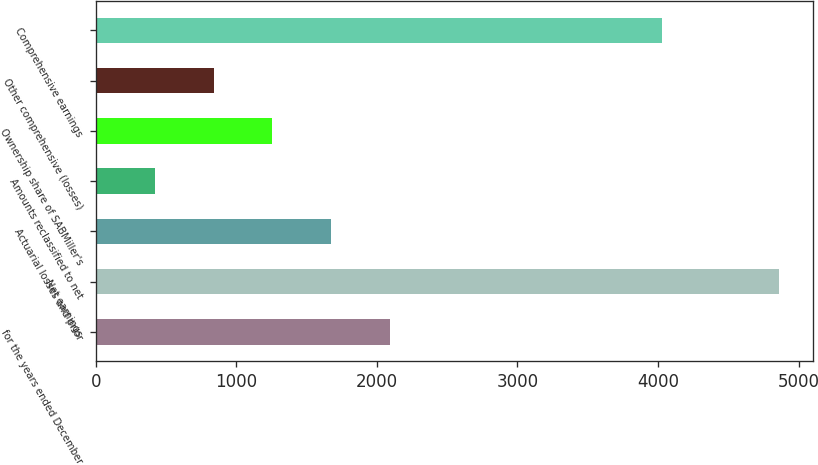Convert chart to OTSL. <chart><loc_0><loc_0><loc_500><loc_500><bar_chart><fcel>for the years ended December<fcel>Net earnings<fcel>Actuarial losses and prior<fcel>Amounts reclassified to net<fcel>Ownership share of SABMiller's<fcel>Other comprehensive (losses)<fcel>Comprehensive earnings<nl><fcel>2093<fcel>4863<fcel>1675<fcel>421<fcel>1257<fcel>839<fcel>4027<nl></chart> 